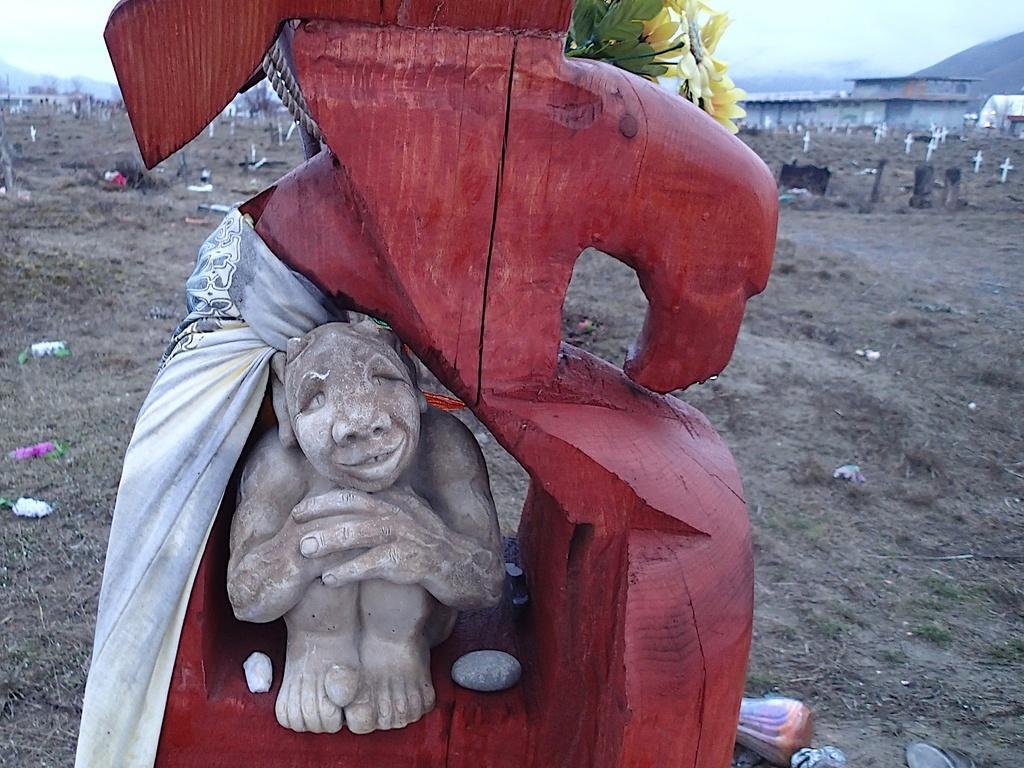Please provide a concise description of this image. This image consists of a sculpture. It looks like it is made up of wood. At the bottom, there is ground. In the background, there is a building. At the top, there is sky. On the right, there is a mountain. 